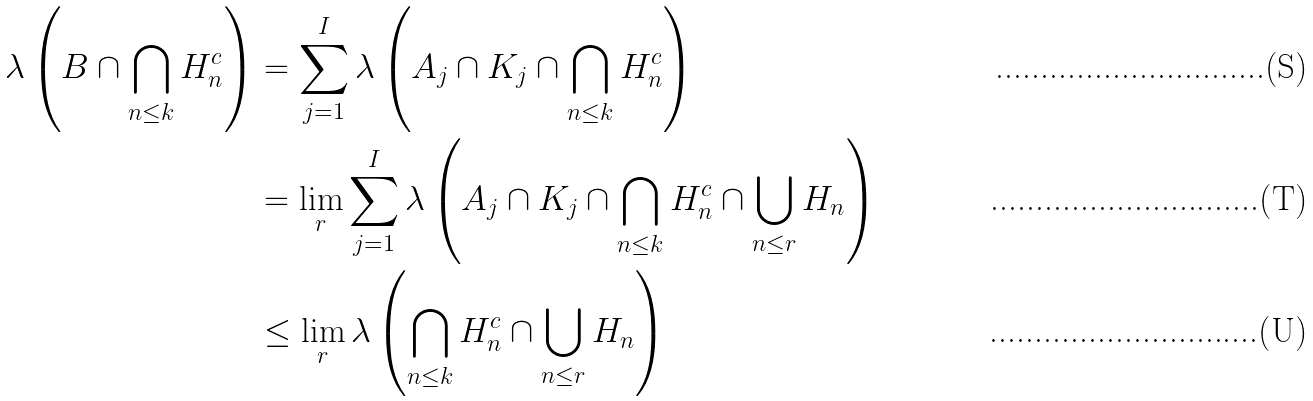<formula> <loc_0><loc_0><loc_500><loc_500>\lambda \left ( B \cap \bigcap _ { n \leq k } H _ { n } ^ { c } \right ) & = \sum _ { j = 1 } ^ { I } \lambda \left ( A _ { j } \cap K _ { j } \cap \bigcap _ { n \leq k } H _ { n } ^ { c } \right ) \\ & = \lim _ { r } \sum _ { j = 1 } ^ { I } \lambda \left ( A _ { j } \cap K _ { j } \cap \bigcap _ { n \leq k } H _ { n } ^ { c } \cap \bigcup _ { n \leq r } H _ { n } \right ) \\ & \leq \lim _ { r } \lambda \left ( \bigcap _ { n \leq k } H _ { n } ^ { c } \cap \bigcup _ { n \leq r } H _ { n } \right )</formula> 